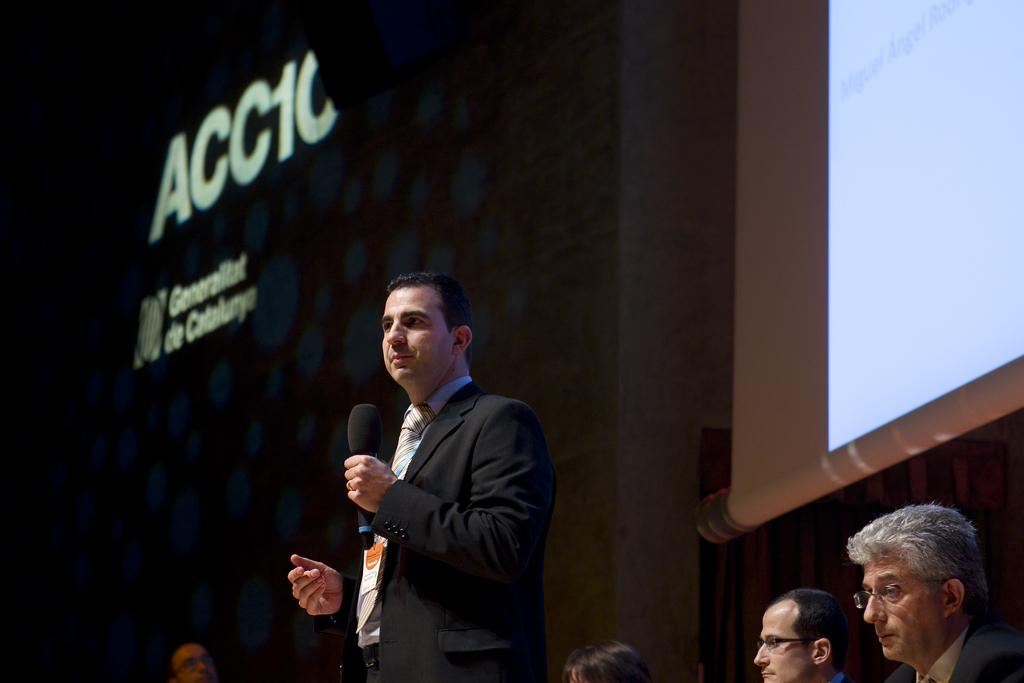How many people are in the image? There are persons in the image. What is the person in the middle doing? The person in the middle is holding a mic. What can be seen on the wall in the image? There is a wall with text visible in the image. What is on the right side of the image? There is a projected screen on the right side of the image. What type of worm can be seen crawling on the projected screen in the image? There is no worm present in the image; the projected screen is the only item visible on the right side of the image. 